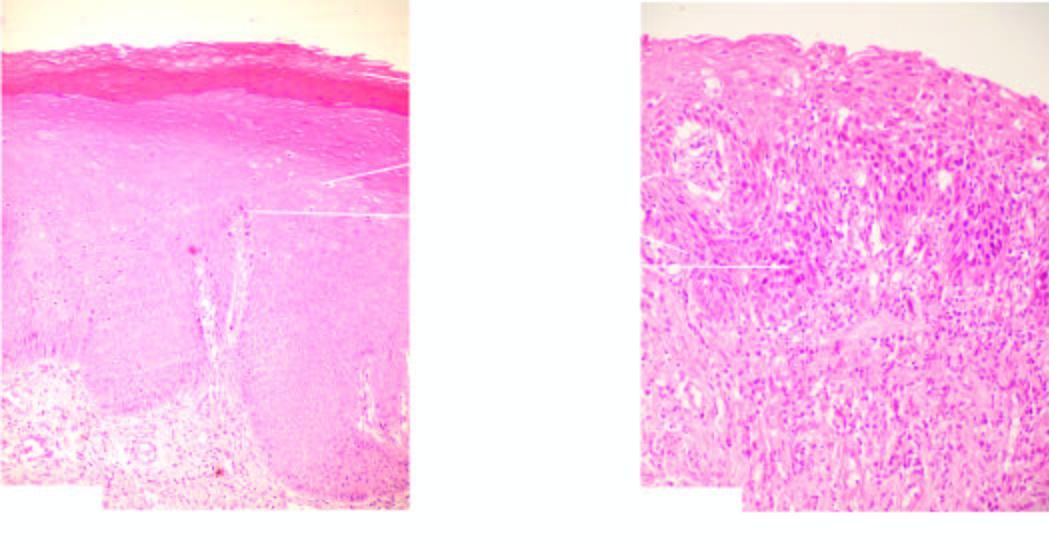s there keratosis and orderly arrangement of increased number of layers of stratified mucosa?
Answer the question using a single word or phrase. Yes 